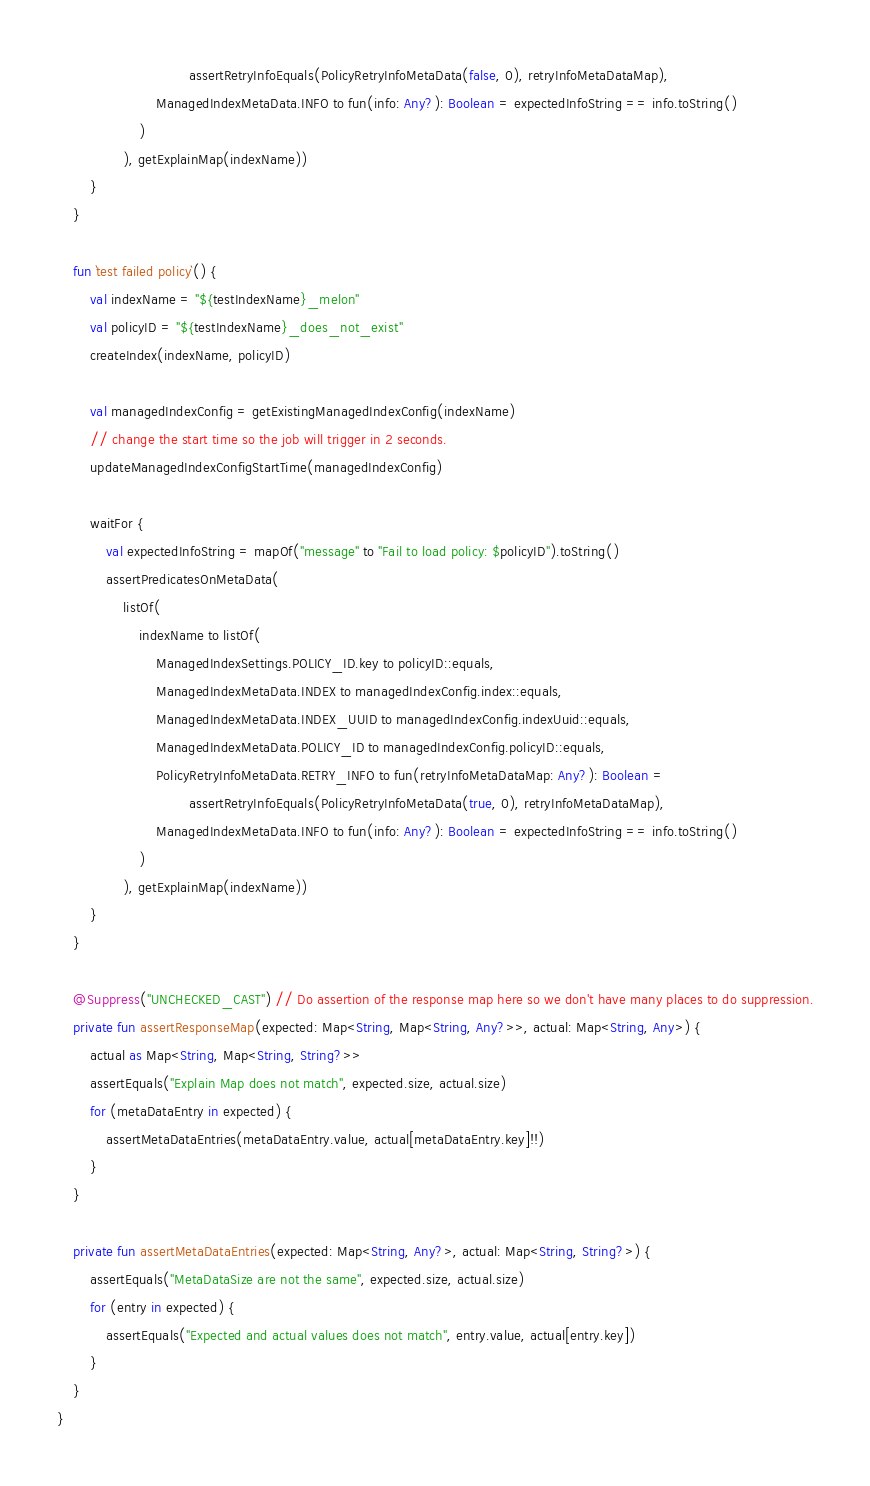Convert code to text. <code><loc_0><loc_0><loc_500><loc_500><_Kotlin_>                                assertRetryInfoEquals(PolicyRetryInfoMetaData(false, 0), retryInfoMetaDataMap),
                        ManagedIndexMetaData.INFO to fun(info: Any?): Boolean = expectedInfoString == info.toString()
                    )
                ), getExplainMap(indexName))
        }
    }

    fun `test failed policy`() {
        val indexName = "${testIndexName}_melon"
        val policyID = "${testIndexName}_does_not_exist"
        createIndex(indexName, policyID)

        val managedIndexConfig = getExistingManagedIndexConfig(indexName)
        // change the start time so the job will trigger in 2 seconds.
        updateManagedIndexConfigStartTime(managedIndexConfig)

        waitFor {
            val expectedInfoString = mapOf("message" to "Fail to load policy: $policyID").toString()
            assertPredicatesOnMetaData(
                listOf(
                    indexName to listOf(
                        ManagedIndexSettings.POLICY_ID.key to policyID::equals,
                        ManagedIndexMetaData.INDEX to managedIndexConfig.index::equals,
                        ManagedIndexMetaData.INDEX_UUID to managedIndexConfig.indexUuid::equals,
                        ManagedIndexMetaData.POLICY_ID to managedIndexConfig.policyID::equals,
                        PolicyRetryInfoMetaData.RETRY_INFO to fun(retryInfoMetaDataMap: Any?): Boolean =
                                assertRetryInfoEquals(PolicyRetryInfoMetaData(true, 0), retryInfoMetaDataMap),
                        ManagedIndexMetaData.INFO to fun(info: Any?): Boolean = expectedInfoString == info.toString()
                    )
                ), getExplainMap(indexName))
        }
    }

    @Suppress("UNCHECKED_CAST") // Do assertion of the response map here so we don't have many places to do suppression.
    private fun assertResponseMap(expected: Map<String, Map<String, Any?>>, actual: Map<String, Any>) {
        actual as Map<String, Map<String, String?>>
        assertEquals("Explain Map does not match", expected.size, actual.size)
        for (metaDataEntry in expected) {
            assertMetaDataEntries(metaDataEntry.value, actual[metaDataEntry.key]!!)
        }
    }

    private fun assertMetaDataEntries(expected: Map<String, Any?>, actual: Map<String, String?>) {
        assertEquals("MetaDataSize are not the same", expected.size, actual.size)
        for (entry in expected) {
            assertEquals("Expected and actual values does not match", entry.value, actual[entry.key])
        }
    }
}
</code> 